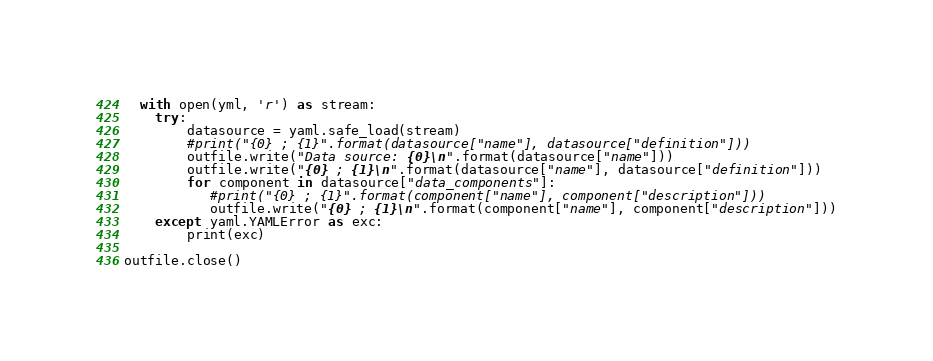Convert code to text. <code><loc_0><loc_0><loc_500><loc_500><_Python_>  with open(yml, 'r') as stream:
    try:        
        datasource = yaml.safe_load(stream)
        #print("{0} ; {1}".format(datasource["name"], datasource["definition"]))
        outfile.write("Data source: {0}\n".format(datasource["name"]))
        outfile.write("{0} ; {1}\n".format(datasource["name"], datasource["definition"]))
        for component in datasource["data_components"]:
           #print("{0} ; {1}".format(component["name"], component["description"]))
           outfile.write("{0} ; {1}\n".format(component["name"], component["description"]))
    except yaml.YAMLError as exc:
        print(exc)

outfile.close()
</code> 